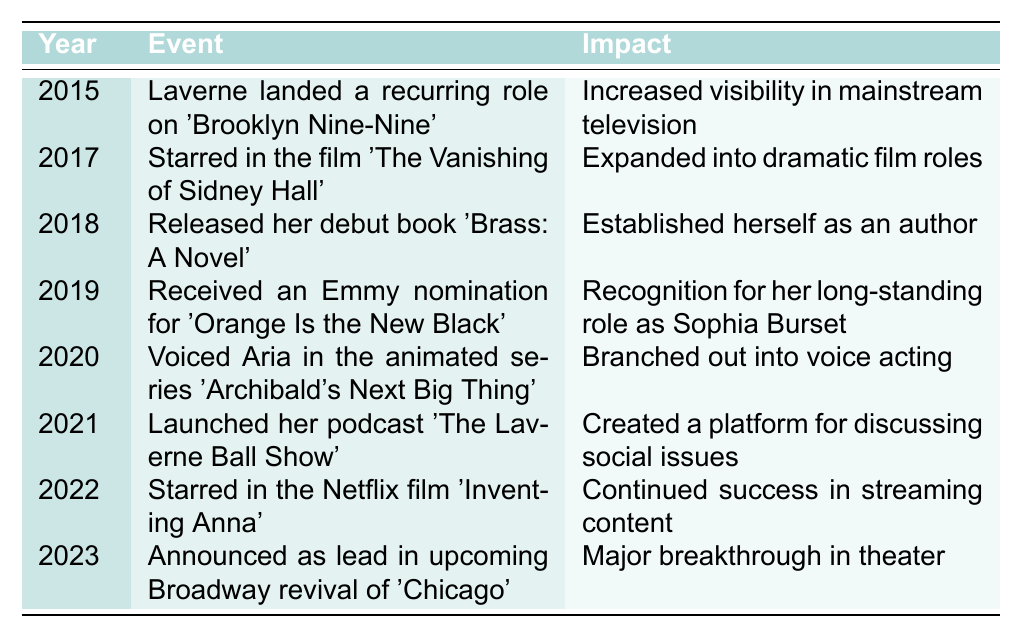What year did Laverne release her debut book? The table lists the events in chronological order with their corresponding years. Looking at the year and event for her debut book, it indicates that she released it in 2018.
Answer: 2018 Which event marks Laverne's entry into voice acting? By examining the events listed, the event indicating her entry into voice acting is from the year 2020, where she voiced Aria in an animated series.
Answer: Voiced Aria in 'Archibald's Next Big Thing' (2020) Did Laverne receive an Emmy nomination for her role on 'Orange Is the New Black'? The table explicitly states in the year 2019 that she received an Emmy nomination for her long-standing role, which confirms she did receive a nomination.
Answer: Yes What is the most recent event in Laverne's career? To determine the most recent event, we look at the table, focusing on the year column. The latest year listed is 2023, where she announced her lead role in a Broadway revival.
Answer: Announced as lead in 'Chicago' (2023) How many events listed occurred between 2015 and 2020? We count the events listed in the years from 2015 to 2020, which includes 2015, 2017, 2018, 2019, and 2020. This totals five events.
Answer: 5 Which event had the greatest impact in terms of visibility? By analyzing the impacts listed, the event in 2015, where Laverne landed a recurring role on 'Brooklyn Nine-Nine', is described as increasing visibility in mainstream television, indicating it had a significant impact on her career visibility.
Answer: Increased visibility in mainstream television (2015) What year did Laverne expand into dramatic film roles? The entry in 2017 shows that she starred in the film 'The Vanishing of Sidney Hall', which is the event that indicates her expansion into dramatic film roles.
Answer: 2017 How many years are there between Laverne's Emmy nomination and her podcast launch? The Emmy nomination took place in 2019, and her podcast was launched in 2021. Calculating the difference gives us 2021 - 2019 = 2 years.
Answer: 2 years Which event signifies a breakthrough in theater for Laverne? Looking at the table, the 2023 event where she was announced as the lead in the Broadway revival of 'Chicago' signifies a major breakthrough in theater.
Answer: Announced as lead in 'Chicago' (2023) What events indicate her progression to a broader media presence? The events that indicate her progression include the recurring role in a television series in 2015, her debut book in 2018, and the launch of her podcast in 2021, showcasing her growth across television, literature, and podcasting.
Answer: 2015, 2018, 2021 